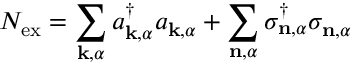Convert formula to latex. <formula><loc_0><loc_0><loc_500><loc_500>N _ { e x } = \sum _ { k , \alpha } a _ { k , \alpha } ^ { \dagger } a _ { k , \alpha } + \sum _ { n , \alpha } \sigma _ { n , \alpha } ^ { \dagger } \sigma _ { n , \alpha }</formula> 